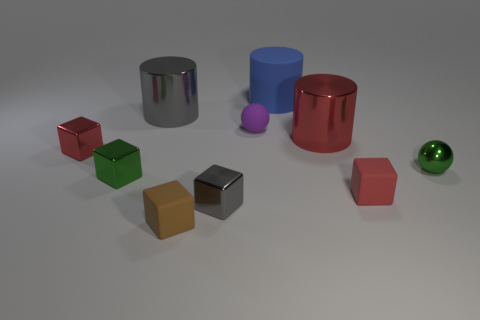There is a green metallic object to the left of the sphere to the right of the tiny red block that is in front of the green cube; what shape is it?
Ensure brevity in your answer.  Cube. The red cylinder has what size?
Your answer should be compact. Large. What is the color of the big object that is made of the same material as the tiny purple ball?
Keep it short and to the point. Blue. What number of small spheres have the same material as the blue cylinder?
Keep it short and to the point. 1. What is the color of the cube that is to the left of the green object to the left of the brown block?
Keep it short and to the point. Red. What is the color of the sphere that is the same size as the purple rubber thing?
Make the answer very short. Green. Are there any other objects that have the same shape as the tiny purple object?
Your response must be concise. Yes. The tiny purple rubber thing is what shape?
Ensure brevity in your answer.  Sphere. Are there more rubber spheres that are in front of the blue rubber object than big red objects that are behind the small purple ball?
Your response must be concise. Yes. What number of other things are the same size as the rubber ball?
Make the answer very short. 6. 